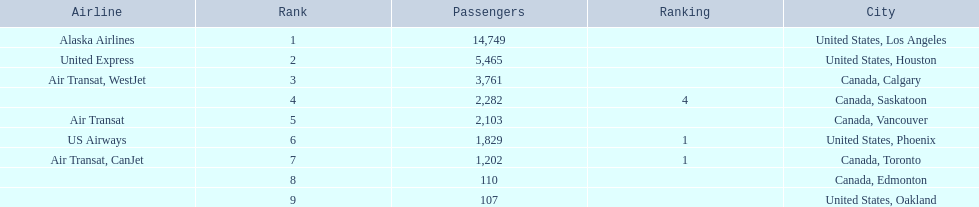Which airport has the least amount of passengers? 107. What airport has 107 passengers? United States, Oakland. 